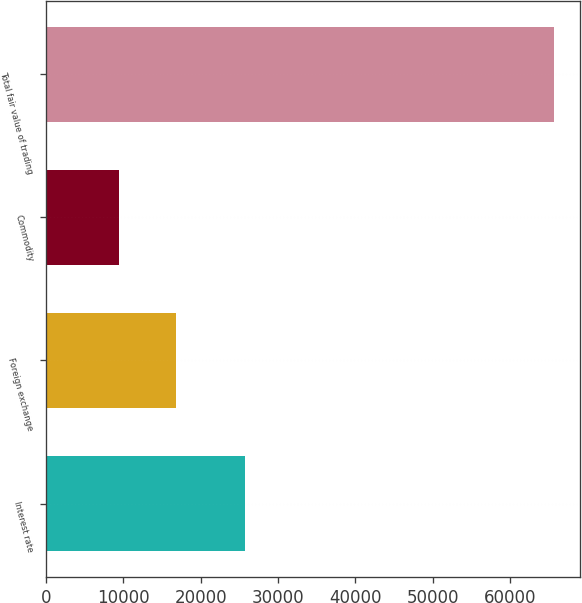Convert chart. <chart><loc_0><loc_0><loc_500><loc_500><bar_chart><fcel>Interest rate<fcel>Foreign exchange<fcel>Commodity<fcel>Total fair value of trading<nl><fcel>25782<fcel>16790<fcel>9444<fcel>65759<nl></chart> 